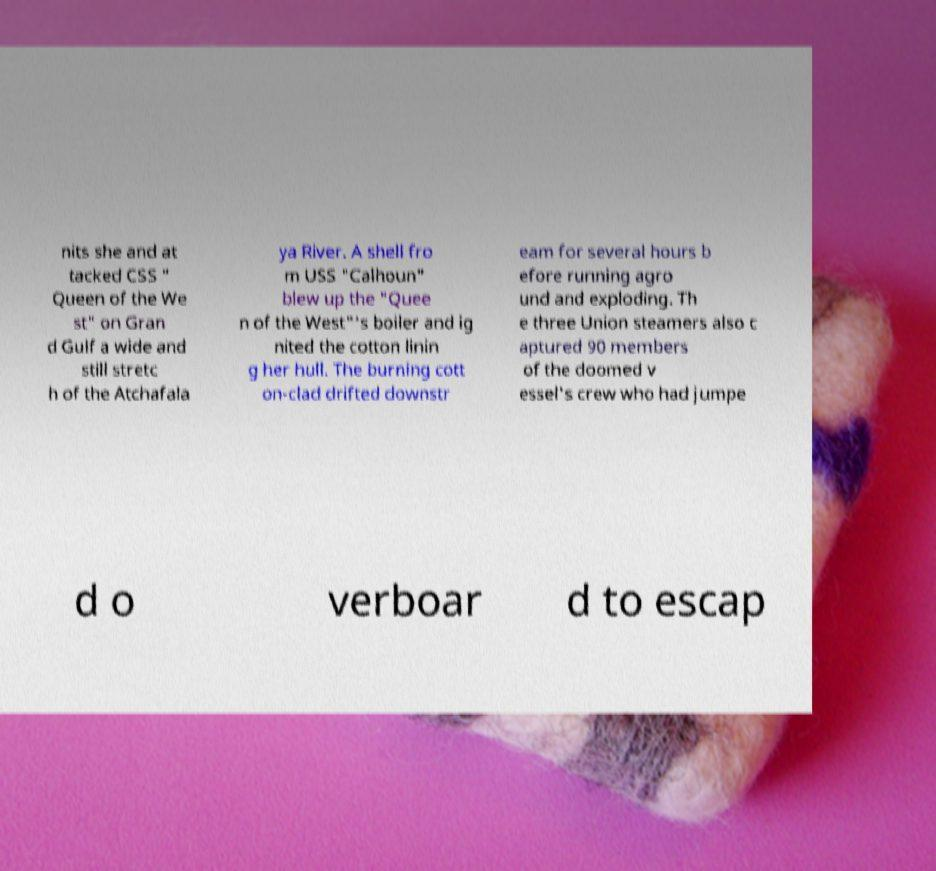Can you read and provide the text displayed in the image?This photo seems to have some interesting text. Can you extract and type it out for me? nits she and at tacked CSS " Queen of the We st" on Gran d Gulf a wide and still stretc h of the Atchafala ya River. A shell fro m USS "Calhoun" blew up the "Quee n of the West"'s boiler and ig nited the cotton linin g her hull. The burning cott on-clad drifted downstr eam for several hours b efore running agro und and exploding. Th e three Union steamers also c aptured 90 members of the doomed v essel's crew who had jumpe d o verboar d to escap 